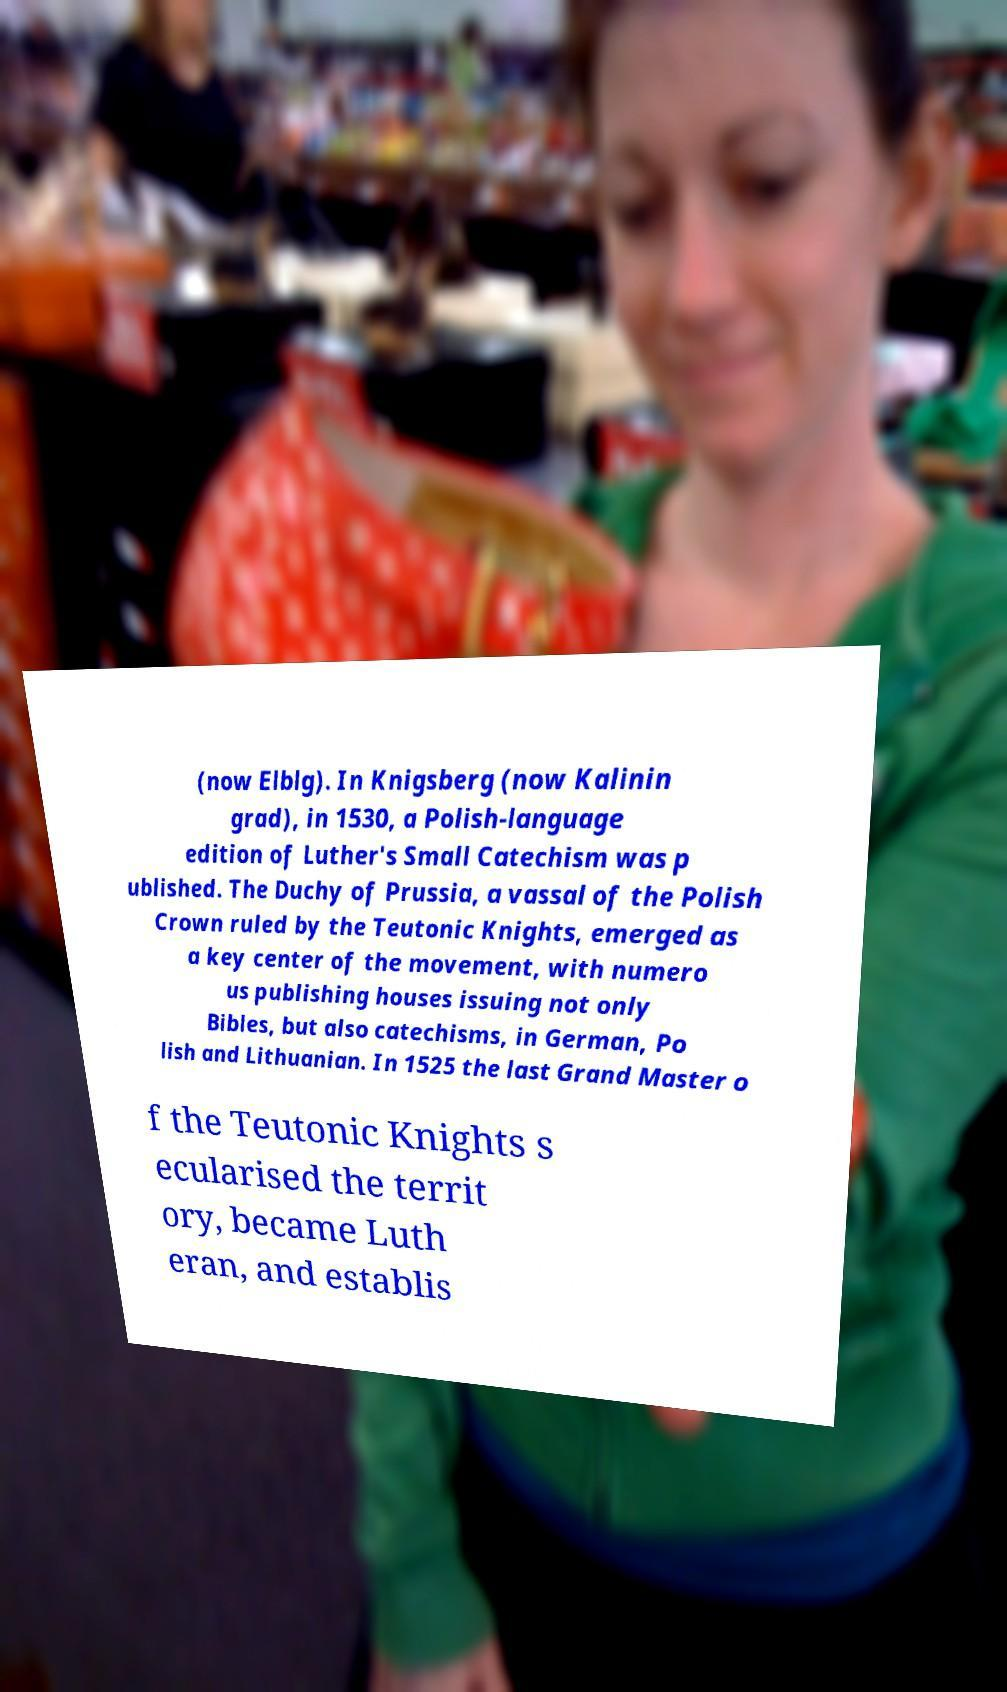Can you read and provide the text displayed in the image?This photo seems to have some interesting text. Can you extract and type it out for me? (now Elblg). In Knigsberg (now Kalinin grad), in 1530, a Polish-language edition of Luther's Small Catechism was p ublished. The Duchy of Prussia, a vassal of the Polish Crown ruled by the Teutonic Knights, emerged as a key center of the movement, with numero us publishing houses issuing not only Bibles, but also catechisms, in German, Po lish and Lithuanian. In 1525 the last Grand Master o f the Teutonic Knights s ecularised the territ ory, became Luth eran, and establis 